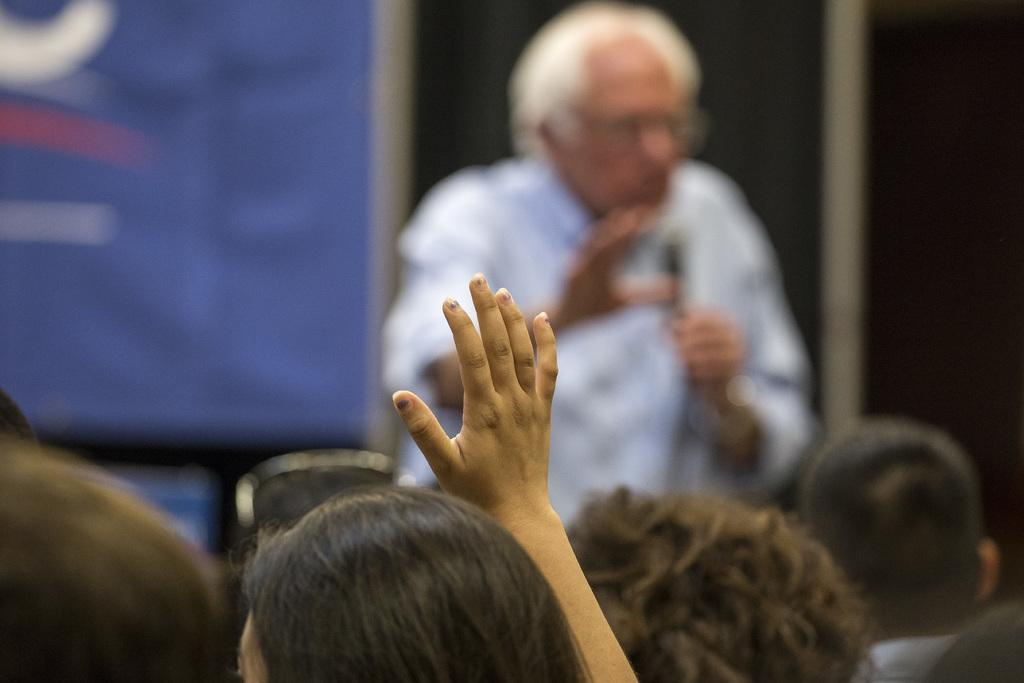What is happening at the bottom of the image? There are people at the bottom of the image. Can you describe the person in the center of the image? The person in the center is holding a mic in his hand. What can be seen in the background of the image? There is a banner in the background of the image. What type of creature is holding the mic in the image? There is no creature present in the image; it is a person holding the mic. What kind of pancake is being served on the banner in the background? There is no pancake mentioned or depicted in the image; the banner is not related to food. 